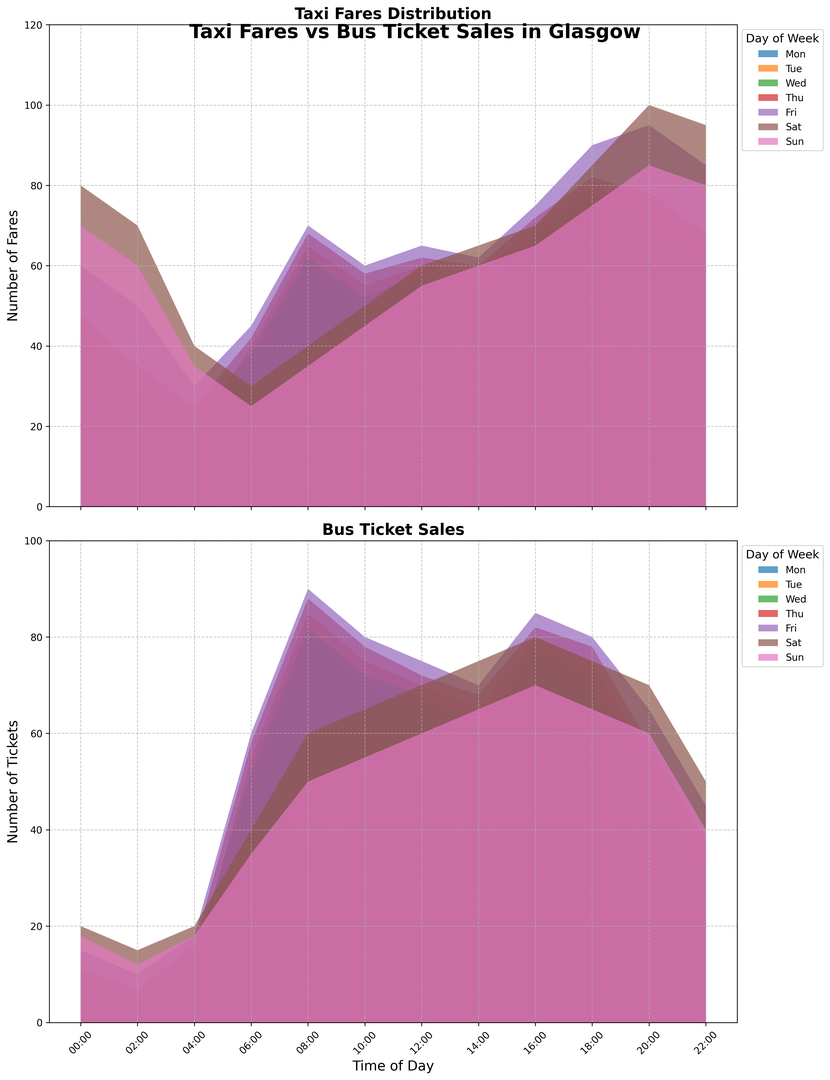What time of day sees the peak in taxi fares on Saturdays? By examining the Taxi Fares Distribution chart, you will see the highest peak for Saturday occurs at a specific time. Based on the height of the filled area, you can identify that the peak is at 20:00 hours.
Answer: 20:00 Which day has the highest overall bus ticket sales at 08:00? Look at the height of the filled areas for the bus ticket sales at 08:00. The tallest peak represents the highest value, which corresponds to Friday.
Answer: Friday What is the difference in taxi fares between Monday at 00:00 and Friday at 00:00? Locate the taxi fares for Monday and Friday at 00:00 from the Taxi Fares Distribution chart. Monday has 45, and Friday has 60. Subtract 45 from 60 to get the difference.
Answer: 15 During which time of day is the difference between taxi fares and bus ticket sales the smallest on Sundays? Examine the charts for both taxi fares and bus ticket sales on Sundays to determine when the difference (depicted visually as the space between the two lines) is minimal. This occurs at 04:00 when the values for both are closest.
Answer: 04:00 What time of day shows the steepest increase in bus ticket sales on Wednesdays? Look at the slope of the filled area in the Bus Ticket Sales chart for Wednesdays. The steepest increase, represented by the sharpest upward slope, occurs between 04:00 and 06:00.
Answer: 04:00 to 06:00 Compare the taxi fares at 18:00 on Fridays to the fares at 18:00 on Sundays. Which day has higher fares? Check the height of the Saturday and Sunday filled areas at 18:00 in the Taxi Fares Distribution chart. Friday has 90, while Sunday has 75. Friday has higher fares.
Answer: Friday At what time on Tuesdays do bus ticket sales surpass those on Mondays? Review the Bus Ticket Sales chart and compare the heights for Monday and Tuesday at each time slot. The ticket sales for Tuesday surpass Monday's at 06:00.
Answer: 06:00 Which day has the lowest bus ticket sales at 22:00? Scan the Bus Ticket Sales chart for the height of the filled areas at 22:00 and find the smallest one. Wednesday's sales are the lowest.
Answer: Wednesday Summing the taxi fares at 12:00 on Monday, Wednesday, and Friday, what total does it come to? Add the taxi fares from the Taxi Fares Distribution chart at 12:00 for Monday (55), Wednesday (58), and Friday (65). 55 + 58 + 65 = 178.
Answer: 178 